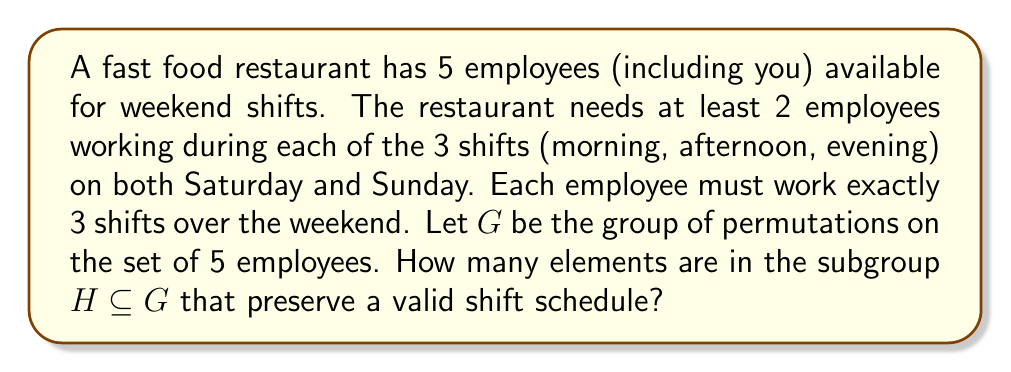Teach me how to tackle this problem. Let's approach this step-by-step:

1) First, we need to understand what a valid shift schedule looks like. We have:
   - 6 shifts total (3 on Saturday, 3 on Sunday)
   - Each shift needs 2 employees
   - Each employee works 3 shifts

2) This means that each shift will have 2 employees, and each employee will appear in exactly 3 shifts. We can represent this as a 6x5 binary matrix where rows are shifts and columns are employees.

3) Now, let's consider the group $G$ of permutations on 5 employees. $|G| = 5! = 120$.

4) The subgroup $H$ we're looking for consists of permutations that, when applied to the columns of our shift matrix, still result in a valid schedule.

5) In fact, any permutation of the employees will result in a valid schedule, because:
   - It doesn't change the number of employees per shift (still 2)
   - It doesn't change the number of shifts per employee (still 3)

6) Therefore, $H = G$, and $|H| = |G| = 120$.

This problem illustrates how algebraic structures (in this case, permutation groups) can be used to analyze scheduling problems in a fast food restaurant context.
Answer: 120 